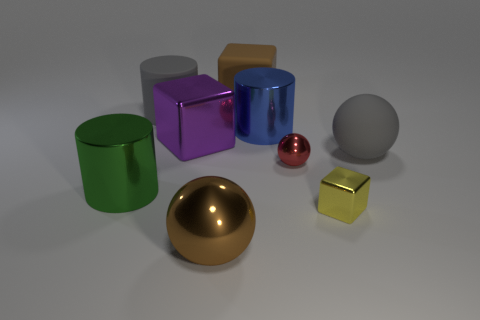Add 1 big balls. How many objects exist? 10 Subtract all cylinders. How many objects are left? 6 Add 2 big green metal cylinders. How many big green metal cylinders are left? 3 Add 9 tiny red matte things. How many tiny red matte things exist? 9 Subtract 0 purple cylinders. How many objects are left? 9 Subtract all big brown objects. Subtract all purple shiny cubes. How many objects are left? 6 